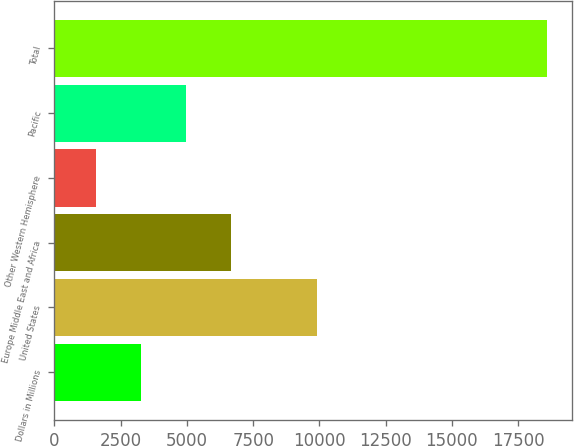Convert chart to OTSL. <chart><loc_0><loc_0><loc_500><loc_500><bar_chart><fcel>Dollars in Millions<fcel>United States<fcel>Europe Middle East and Africa<fcel>Other Western Hemisphere<fcel>Pacific<fcel>Total<nl><fcel>3265.4<fcel>9924<fcel>6674.2<fcel>1561<fcel>4969.8<fcel>18605<nl></chart> 